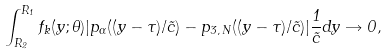<formula> <loc_0><loc_0><loc_500><loc_500>\int _ { R _ { 2 } } ^ { R _ { 1 } } f _ { k } ( y ; \theta ) | p _ { \alpha } ( ( y - \tau ) / \tilde { c } ) - p _ { 3 , \, N } ( ( y - \tau ) / \tilde { c } ) | \frac { 1 } { \tilde { c } } d y \rightarrow 0 ,</formula> 